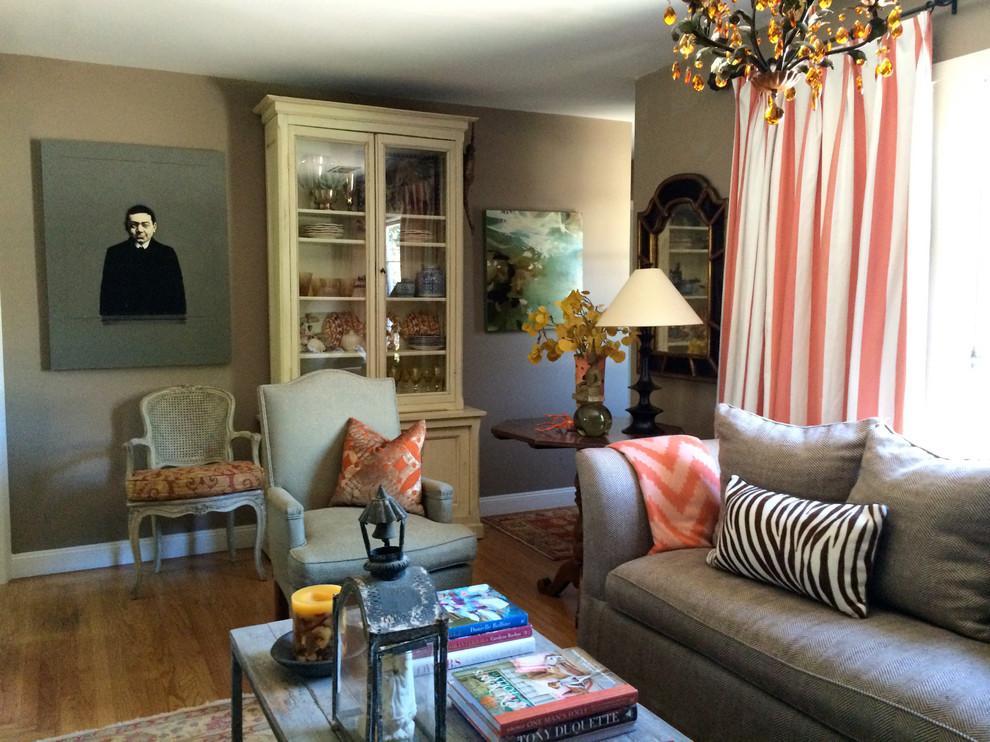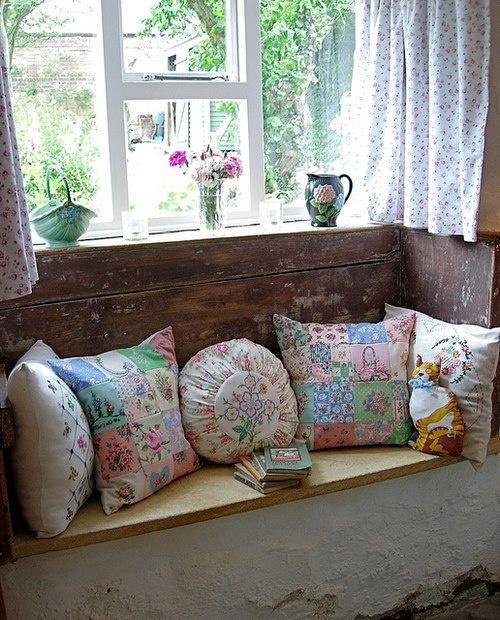The first image is the image on the left, the second image is the image on the right. Analyze the images presented: Is the assertion "One image includes at least one pillow decorated with animal silhouettes." valid? Answer yes or no. No. The first image is the image on the left, the second image is the image on the right. Given the left and right images, does the statement "All images appear to be couches." hold true? Answer yes or no. Yes. 